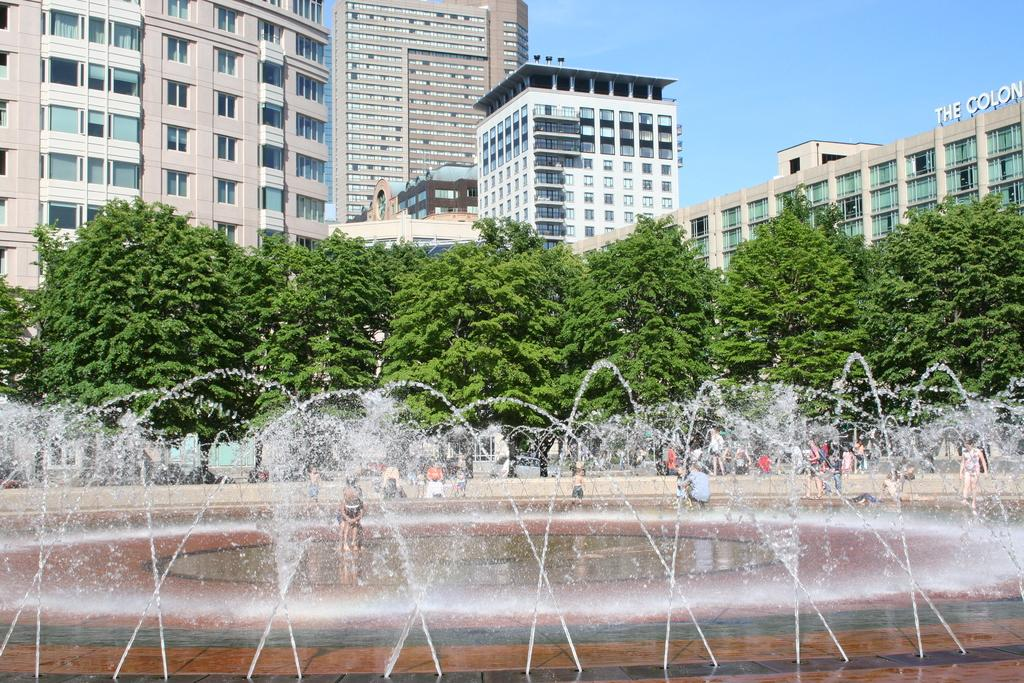What is present in the image that represents a natural element? There is water and trees in the image, which represent natural elements. What type of man-made structures can be seen in the image? There are buildings in the image. What is the purpose of the name board in the image? The name board in the image is likely used for identification or direction. Who or what is present in the image besides the natural and man-made elements? There is a group of people and objects in the image. What can be seen in the background of the image? The sky is visible in the background of the image. How does the account balance change when the group of people in the image touch the joke? There is no account, touching, or joke present in the image. The image features water, trees, buildings, a name board, a group of people, objects, and a visible sky in the background. 